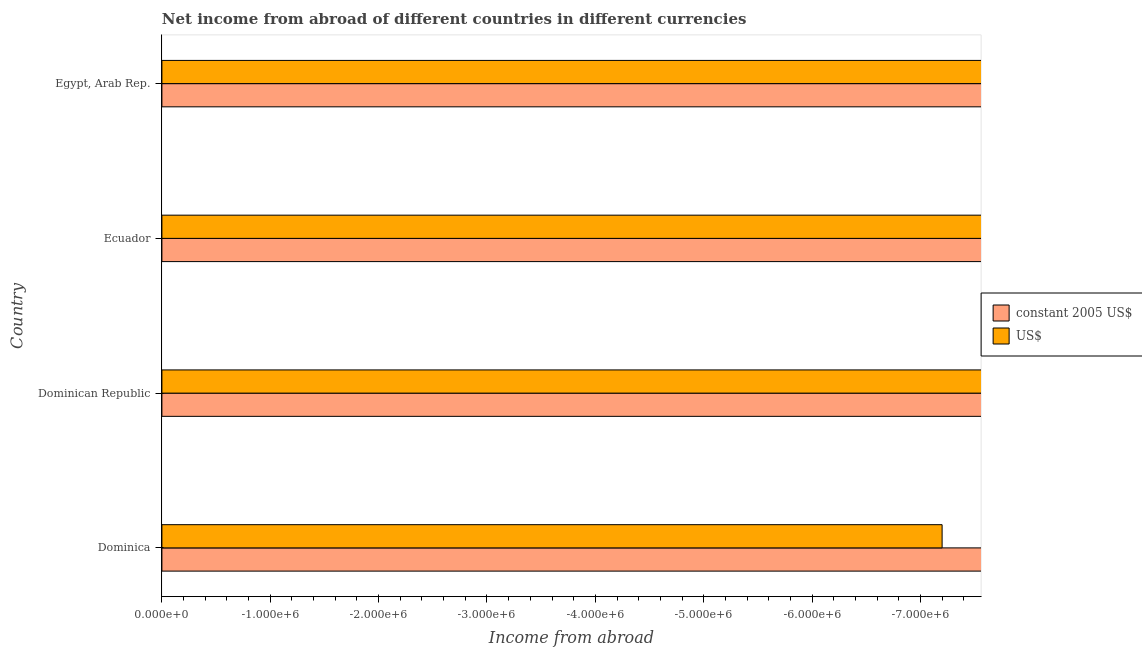How many different coloured bars are there?
Provide a short and direct response. 0. Are the number of bars per tick equal to the number of legend labels?
Make the answer very short. No. Are the number of bars on each tick of the Y-axis equal?
Offer a terse response. Yes. How many bars are there on the 3rd tick from the top?
Make the answer very short. 0. How many bars are there on the 4th tick from the bottom?
Offer a terse response. 0. What is the label of the 2nd group of bars from the top?
Give a very brief answer. Ecuador. What is the income from abroad in constant 2005 us$ in Dominica?
Offer a terse response. 0. What is the difference between the income from abroad in us$ in Ecuador and the income from abroad in constant 2005 us$ in Dominican Republic?
Offer a terse response. 0. What is the average income from abroad in us$ per country?
Provide a short and direct response. 0. How many bars are there?
Give a very brief answer. 0. Are all the bars in the graph horizontal?
Provide a short and direct response. Yes. What is the difference between two consecutive major ticks on the X-axis?
Give a very brief answer. 1.00e+06. Are the values on the major ticks of X-axis written in scientific E-notation?
Your response must be concise. Yes. Does the graph contain any zero values?
Ensure brevity in your answer.  Yes. Does the graph contain grids?
Offer a terse response. No. Where does the legend appear in the graph?
Offer a very short reply. Center right. How many legend labels are there?
Give a very brief answer. 2. How are the legend labels stacked?
Keep it short and to the point. Vertical. What is the title of the graph?
Your answer should be compact. Net income from abroad of different countries in different currencies. Does "Primary" appear as one of the legend labels in the graph?
Provide a succinct answer. No. What is the label or title of the X-axis?
Give a very brief answer. Income from abroad. What is the label or title of the Y-axis?
Ensure brevity in your answer.  Country. What is the Income from abroad of US$ in Dominica?
Your response must be concise. 0. What is the Income from abroad of constant 2005 US$ in Dominican Republic?
Provide a short and direct response. 0. What is the Income from abroad in US$ in Dominican Republic?
Offer a very short reply. 0. What is the Income from abroad in US$ in Ecuador?
Provide a succinct answer. 0. What is the Income from abroad of constant 2005 US$ in Egypt, Arab Rep.?
Give a very brief answer. 0. What is the total Income from abroad of constant 2005 US$ in the graph?
Your answer should be compact. 0. What is the total Income from abroad in US$ in the graph?
Provide a succinct answer. 0. What is the average Income from abroad in constant 2005 US$ per country?
Make the answer very short. 0. What is the average Income from abroad in US$ per country?
Ensure brevity in your answer.  0. 